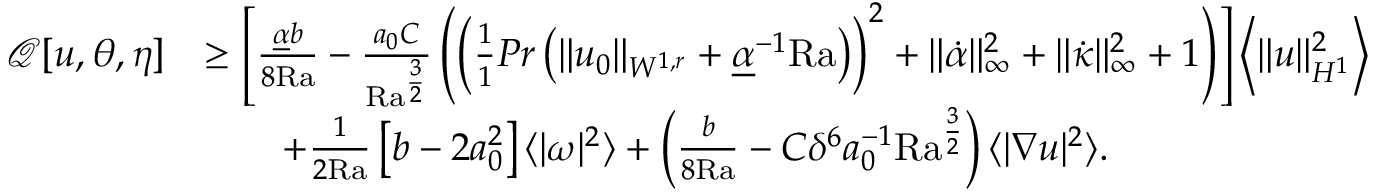<formula> <loc_0><loc_0><loc_500><loc_500>\begin{array} { r l } { \mathcal { Q } [ u , \theta , \eta ] } & { \geq \left [ \frac { \underline { \alpha } b } { 8 { R a } } - \frac { a _ { 0 } C } { { R a } ^ { \frac { 3 } { 2 } } } \left ( \left ( \frac { 1 } { 1 } { P r } \left ( \| u _ { 0 } \| _ { W ^ { 1 , r } } + \underline { \alpha } ^ { - 1 } { R a } \right ) \right ) ^ { 2 } + \| \dot { \alpha } \| _ { \infty } ^ { 2 } + \| \dot { \kappa } \| _ { \infty } ^ { 2 } + 1 \right ) \right ] \left \langle \| u \| _ { H ^ { 1 } } ^ { 2 } \right \rangle } \\ & { \quad + \frac { 1 } { 2 { R a } } \left [ b - 2 a _ { 0 } ^ { 2 } \right ] \langle | \omega | ^ { 2 } \rangle + \left ( \frac { b } { 8 { R a } } - C \delta ^ { 6 } a _ { 0 } ^ { - 1 } { R a } ^ { \frac { 3 } { 2 } } \right ) \langle | \nabla u | ^ { 2 } \rangle . } \end{array}</formula> 